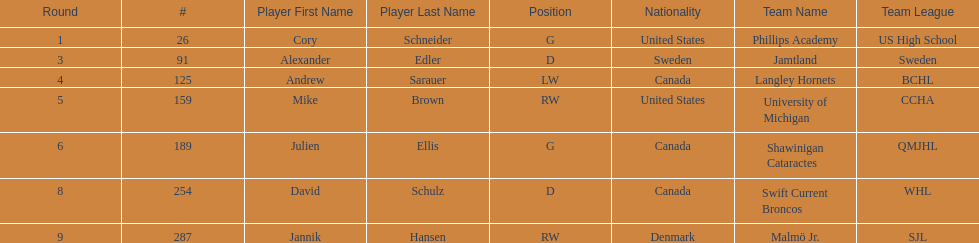The first round not to have a draft pick. 2. 